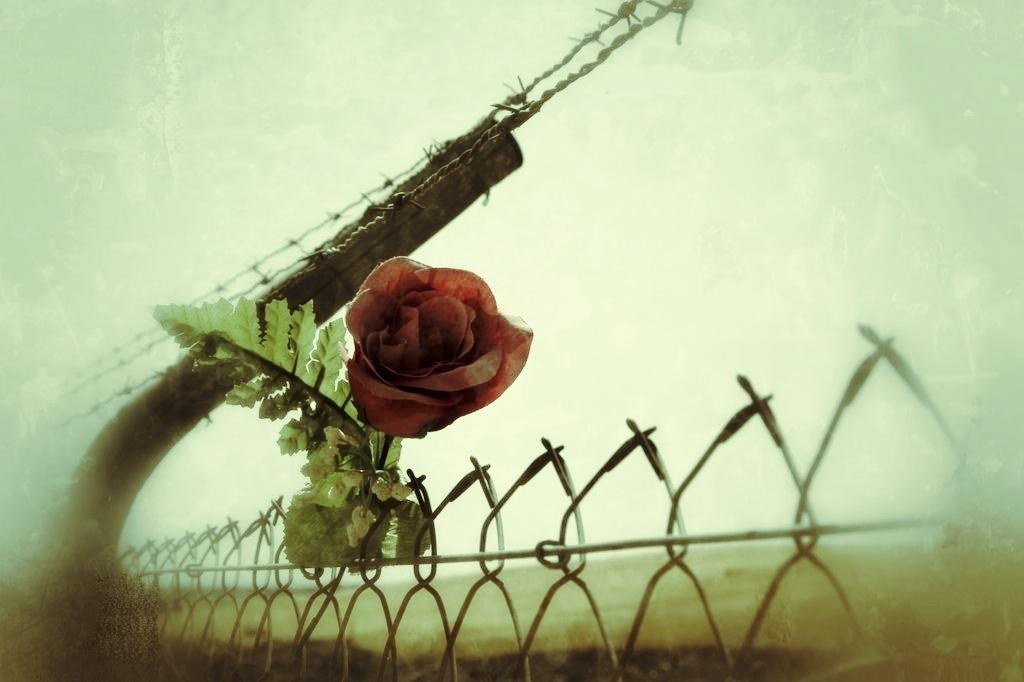What type of flower is in the image? There is a rose flower in the image. What else can be seen in the image besides the flower? There are leaves and a fence visible in the image. What is visible in the background of the image? The sky is visible in the background of the image. What type of lace is being used to decorate the rabbit in the image? There is no rabbit or lace present in the image; it features a rose flower, leaves, a fence, and the sky. 